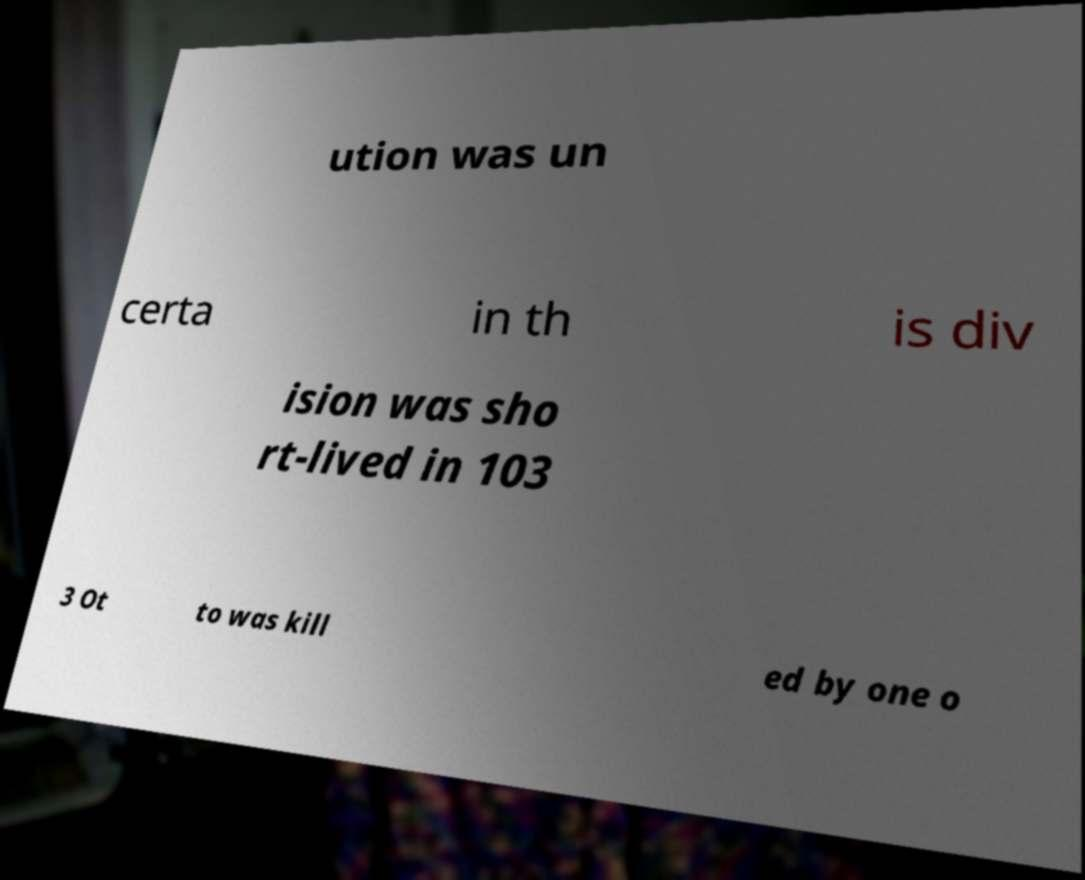Can you accurately transcribe the text from the provided image for me? ution was un certa in th is div ision was sho rt-lived in 103 3 Ot to was kill ed by one o 